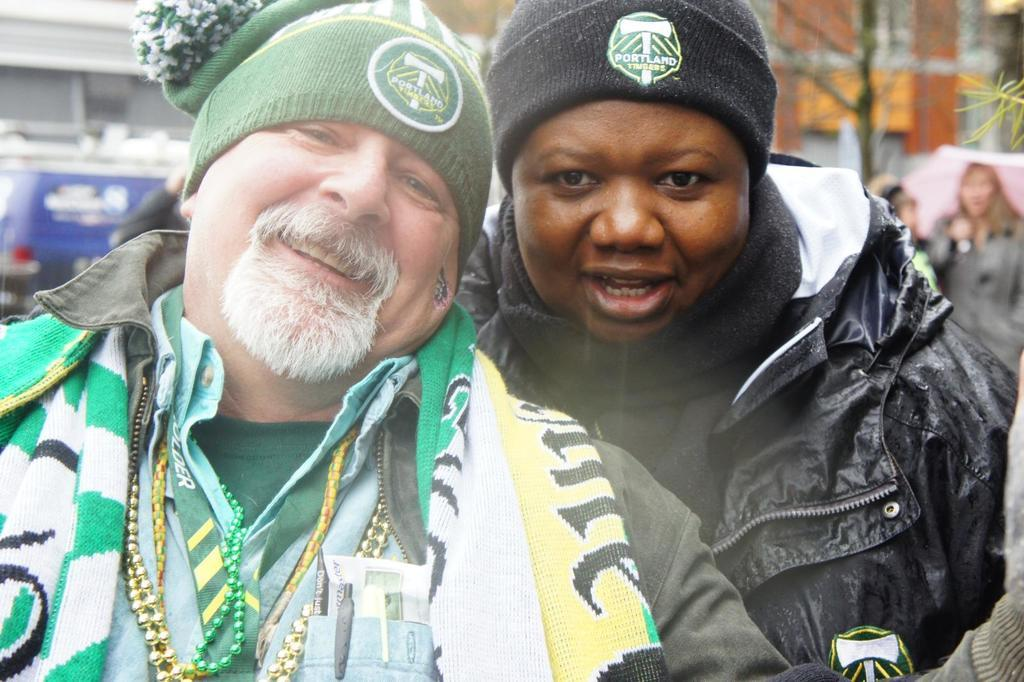How many men are in the image? There are two men in the image. What are the men wearing? The men are wearing jackets and caps. What are the men doing in the image? The men are posing for a photograph. Can you describe the background of the image? There are persons, vehicles, and buildings in the background of the image. What type of vein can be seen on the men's faces in the image? There are no visible veins on the men's faces in the image. How does the regret of the men manifest in the image? There is no indication of regret in the image; the men are posing for a photograph. 